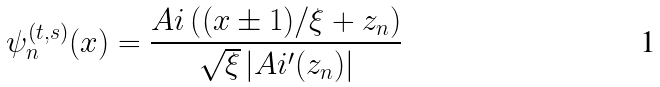<formula> <loc_0><loc_0><loc_500><loc_500>\psi _ { n } ^ { ( t , s ) } ( x ) = \frac { A i \left ( ( x \pm 1 ) / \xi + z _ { n } \right ) } { \sqrt { \xi } \left | A i ^ { \prime } ( z _ { n } ) \right | }</formula> 